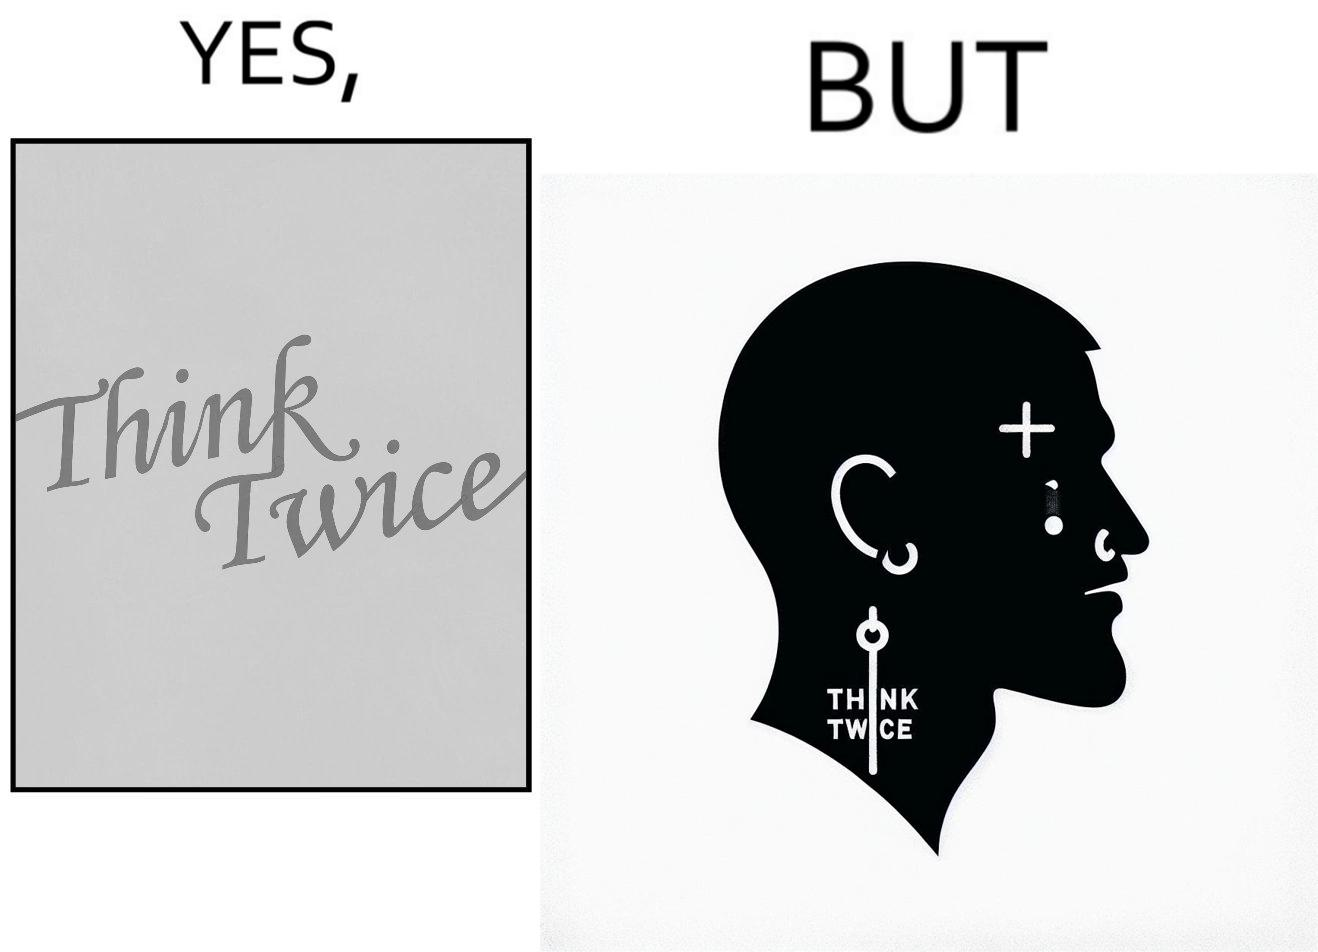Describe the contrast between the left and right parts of this image. In the left part of the image: The image shows a text in english saying "Think Twice". The font seems very fashionable. In the right part of the image: The image shows the face of a man with a tattoo on the left side of a forehead saying "Think Twice". The man is wearing a nose ring and has a cut on his left eyebrow. He also has a small tattoo of the cross a little below his left eye. 